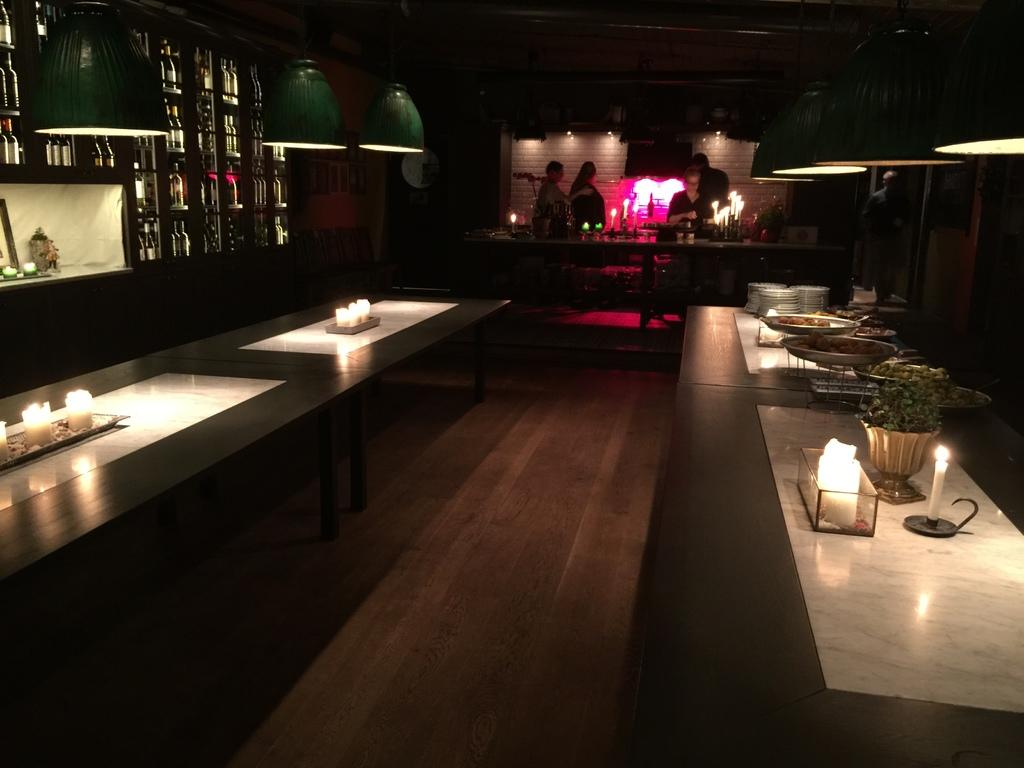What type of furniture is visible in the image? There are tables in the image. What objects can be seen on the tables? Candles and a flower vase are present on the tables. How is the wall decorated in the image? The wall is decorated with bottles. How many people are in the image? There are four persons standing in the image. What is the surface visible beneath the tables? The image shows a floor. What type of ocean can be seen in the image? There is no ocean present in the image. How many girls are in the image? The provided facts do not mention the gender of the persons in the image, so we cannot determine the number of girls. 